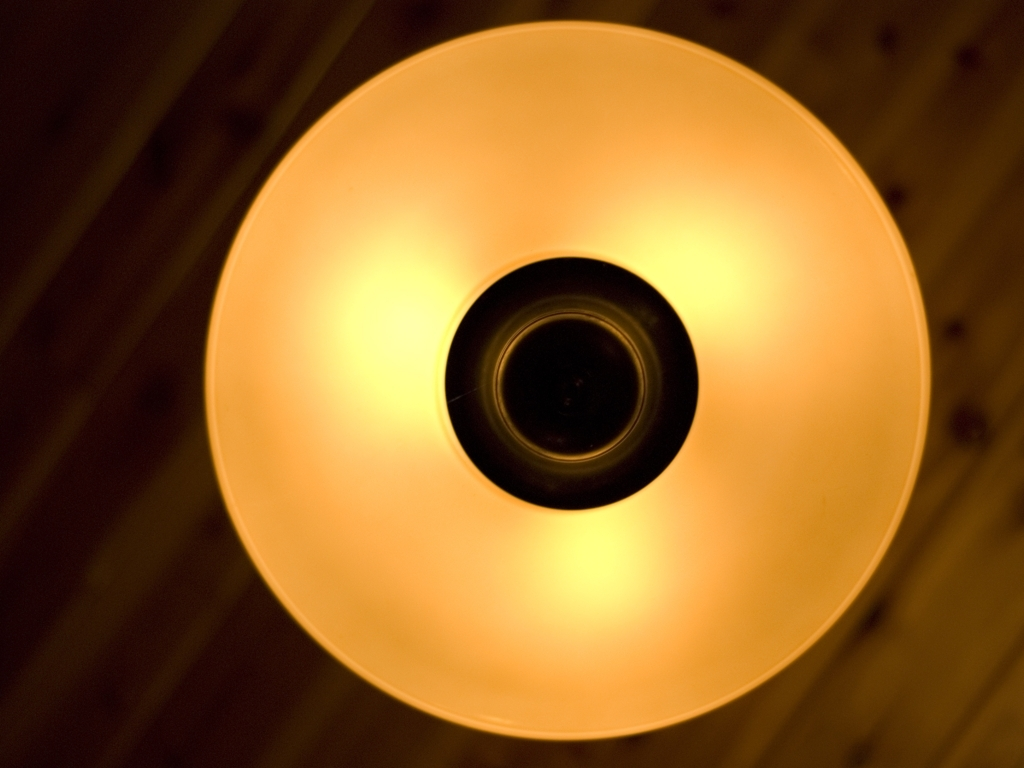What mood does the lighting in this image evoke? The warm golden hue emitted by the light fixture creates a cozy and inviting atmosphere, which might evoke feelings of relaxation and comfort, akin to being in a serene, dimly-lit café or a peaceful living room in the evening. 